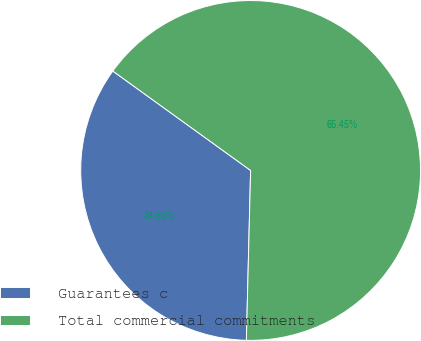<chart> <loc_0><loc_0><loc_500><loc_500><pie_chart><fcel>Guarantees c<fcel>Total commercial commitments<nl><fcel>34.55%<fcel>65.45%<nl></chart> 